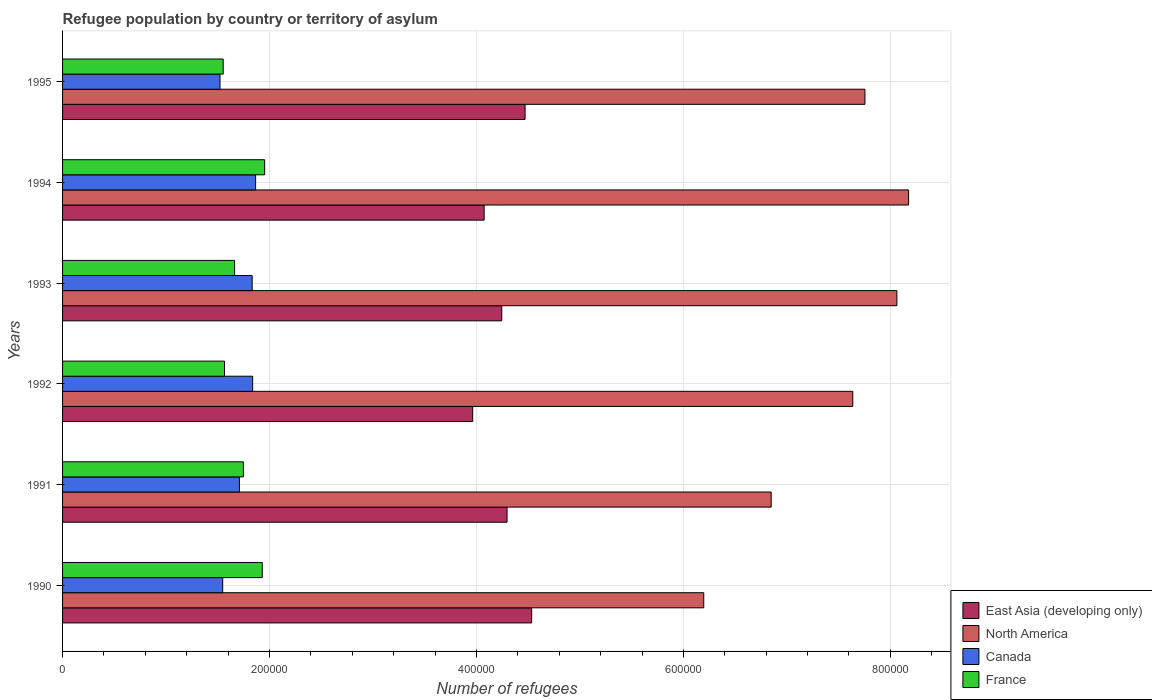How many different coloured bars are there?
Make the answer very short. 4. How many groups of bars are there?
Offer a terse response. 6. Are the number of bars per tick equal to the number of legend labels?
Provide a short and direct response. Yes. How many bars are there on the 5th tick from the top?
Offer a terse response. 4. How many bars are there on the 6th tick from the bottom?
Make the answer very short. 4. In how many cases, is the number of bars for a given year not equal to the number of legend labels?
Ensure brevity in your answer.  0. What is the number of refugees in East Asia (developing only) in 1992?
Provide a succinct answer. 3.96e+05. Across all years, what is the maximum number of refugees in Canada?
Give a very brief answer. 1.87e+05. Across all years, what is the minimum number of refugees in North America?
Your answer should be very brief. 6.20e+05. In which year was the number of refugees in Canada maximum?
Offer a terse response. 1994. In which year was the number of refugees in North America minimum?
Your answer should be compact. 1990. What is the total number of refugees in France in the graph?
Ensure brevity in your answer.  1.04e+06. What is the difference between the number of refugees in France in 1992 and that in 1993?
Your answer should be compact. -9757. What is the difference between the number of refugees in East Asia (developing only) in 1994 and the number of refugees in France in 1991?
Your response must be concise. 2.33e+05. What is the average number of refugees in North America per year?
Your answer should be very brief. 7.45e+05. In the year 1995, what is the difference between the number of refugees in North America and number of refugees in East Asia (developing only)?
Provide a short and direct response. 3.28e+05. In how many years, is the number of refugees in Canada greater than 560000 ?
Provide a short and direct response. 0. What is the ratio of the number of refugees in Canada in 1990 to that in 1992?
Offer a very short reply. 0.84. Is the number of refugees in Canada in 1992 less than that in 1994?
Make the answer very short. Yes. What is the difference between the highest and the second highest number of refugees in North America?
Your answer should be compact. 1.13e+04. What is the difference between the highest and the lowest number of refugees in East Asia (developing only)?
Keep it short and to the point. 5.70e+04. Is the sum of the number of refugees in East Asia (developing only) in 1991 and 1992 greater than the maximum number of refugees in North America across all years?
Your answer should be compact. Yes. What does the 1st bar from the top in 1995 represents?
Provide a succinct answer. France. What does the 2nd bar from the bottom in 1991 represents?
Your answer should be very brief. North America. Is it the case that in every year, the sum of the number of refugees in France and number of refugees in Canada is greater than the number of refugees in East Asia (developing only)?
Offer a very short reply. No. Are all the bars in the graph horizontal?
Provide a succinct answer. Yes. How many years are there in the graph?
Your response must be concise. 6. What is the difference between two consecutive major ticks on the X-axis?
Give a very brief answer. 2.00e+05. Are the values on the major ticks of X-axis written in scientific E-notation?
Provide a short and direct response. No. Does the graph contain grids?
Your response must be concise. Yes. How many legend labels are there?
Your answer should be very brief. 4. What is the title of the graph?
Your response must be concise. Refugee population by country or territory of asylum. What is the label or title of the X-axis?
Provide a succinct answer. Number of refugees. What is the label or title of the Y-axis?
Keep it short and to the point. Years. What is the Number of refugees of East Asia (developing only) in 1990?
Provide a succinct answer. 4.53e+05. What is the Number of refugees in North America in 1990?
Ensure brevity in your answer.  6.20e+05. What is the Number of refugees of Canada in 1990?
Your response must be concise. 1.55e+05. What is the Number of refugees in France in 1990?
Your answer should be compact. 1.93e+05. What is the Number of refugees of East Asia (developing only) in 1991?
Provide a succinct answer. 4.30e+05. What is the Number of refugees of North America in 1991?
Make the answer very short. 6.85e+05. What is the Number of refugees in Canada in 1991?
Your answer should be very brief. 1.71e+05. What is the Number of refugees in France in 1991?
Offer a terse response. 1.75e+05. What is the Number of refugees in East Asia (developing only) in 1992?
Ensure brevity in your answer.  3.96e+05. What is the Number of refugees of North America in 1992?
Your response must be concise. 7.64e+05. What is the Number of refugees in Canada in 1992?
Your answer should be compact. 1.84e+05. What is the Number of refugees in France in 1992?
Give a very brief answer. 1.57e+05. What is the Number of refugees in East Asia (developing only) in 1993?
Your answer should be very brief. 4.24e+05. What is the Number of refugees of North America in 1993?
Your answer should be compact. 8.06e+05. What is the Number of refugees of Canada in 1993?
Your response must be concise. 1.83e+05. What is the Number of refugees in France in 1993?
Your answer should be very brief. 1.66e+05. What is the Number of refugees of East Asia (developing only) in 1994?
Your answer should be very brief. 4.07e+05. What is the Number of refugees in North America in 1994?
Keep it short and to the point. 8.18e+05. What is the Number of refugees of Canada in 1994?
Give a very brief answer. 1.87e+05. What is the Number of refugees in France in 1994?
Keep it short and to the point. 1.95e+05. What is the Number of refugees of East Asia (developing only) in 1995?
Your answer should be compact. 4.47e+05. What is the Number of refugees of North America in 1995?
Offer a terse response. 7.75e+05. What is the Number of refugees of Canada in 1995?
Offer a terse response. 1.52e+05. What is the Number of refugees in France in 1995?
Your answer should be compact. 1.55e+05. Across all years, what is the maximum Number of refugees in East Asia (developing only)?
Offer a very short reply. 4.53e+05. Across all years, what is the maximum Number of refugees in North America?
Your answer should be very brief. 8.18e+05. Across all years, what is the maximum Number of refugees of Canada?
Your response must be concise. 1.87e+05. Across all years, what is the maximum Number of refugees of France?
Offer a terse response. 1.95e+05. Across all years, what is the minimum Number of refugees in East Asia (developing only)?
Make the answer very short. 3.96e+05. Across all years, what is the minimum Number of refugees in North America?
Offer a terse response. 6.20e+05. Across all years, what is the minimum Number of refugees in Canada?
Offer a terse response. 1.52e+05. Across all years, what is the minimum Number of refugees in France?
Your answer should be compact. 1.55e+05. What is the total Number of refugees in East Asia (developing only) in the graph?
Ensure brevity in your answer.  2.56e+06. What is the total Number of refugees in North America in the graph?
Ensure brevity in your answer.  4.47e+06. What is the total Number of refugees of Canada in the graph?
Your response must be concise. 1.03e+06. What is the total Number of refugees in France in the graph?
Make the answer very short. 1.04e+06. What is the difference between the Number of refugees in East Asia (developing only) in 1990 and that in 1991?
Your answer should be compact. 2.38e+04. What is the difference between the Number of refugees of North America in 1990 and that in 1991?
Keep it short and to the point. -6.52e+04. What is the difference between the Number of refugees in Canada in 1990 and that in 1991?
Offer a very short reply. -1.62e+04. What is the difference between the Number of refugees in France in 1990 and that in 1991?
Your answer should be very brief. 1.82e+04. What is the difference between the Number of refugees of East Asia (developing only) in 1990 and that in 1992?
Offer a very short reply. 5.70e+04. What is the difference between the Number of refugees of North America in 1990 and that in 1992?
Offer a terse response. -1.44e+05. What is the difference between the Number of refugees in Canada in 1990 and that in 1992?
Offer a very short reply. -2.90e+04. What is the difference between the Number of refugees in France in 1990 and that in 1992?
Make the answer very short. 3.65e+04. What is the difference between the Number of refugees of East Asia (developing only) in 1990 and that in 1993?
Your answer should be compact. 2.89e+04. What is the difference between the Number of refugees in North America in 1990 and that in 1993?
Make the answer very short. -1.87e+05. What is the difference between the Number of refugees of Canada in 1990 and that in 1993?
Offer a terse response. -2.85e+04. What is the difference between the Number of refugees in France in 1990 and that in 1993?
Make the answer very short. 2.67e+04. What is the difference between the Number of refugees in East Asia (developing only) in 1990 and that in 1994?
Keep it short and to the point. 4.59e+04. What is the difference between the Number of refugees in North America in 1990 and that in 1994?
Your answer should be compact. -1.98e+05. What is the difference between the Number of refugees in Canada in 1990 and that in 1994?
Offer a terse response. -3.18e+04. What is the difference between the Number of refugees of France in 1990 and that in 1994?
Offer a very short reply. -2288. What is the difference between the Number of refugees of East Asia (developing only) in 1990 and that in 1995?
Your answer should be compact. 6367. What is the difference between the Number of refugees of North America in 1990 and that in 1995?
Your answer should be very brief. -1.56e+05. What is the difference between the Number of refugees of Canada in 1990 and that in 1995?
Provide a short and direct response. 2636. What is the difference between the Number of refugees of France in 1990 and that in 1995?
Provide a succinct answer. 3.78e+04. What is the difference between the Number of refugees of East Asia (developing only) in 1991 and that in 1992?
Offer a very short reply. 3.32e+04. What is the difference between the Number of refugees of North America in 1991 and that in 1992?
Provide a succinct answer. -7.89e+04. What is the difference between the Number of refugees in Canada in 1991 and that in 1992?
Provide a succinct answer. -1.28e+04. What is the difference between the Number of refugees of France in 1991 and that in 1992?
Your response must be concise. 1.82e+04. What is the difference between the Number of refugees in East Asia (developing only) in 1991 and that in 1993?
Your answer should be compact. 5099. What is the difference between the Number of refugees in North America in 1991 and that in 1993?
Your answer should be very brief. -1.22e+05. What is the difference between the Number of refugees in Canada in 1991 and that in 1993?
Your answer should be very brief. -1.23e+04. What is the difference between the Number of refugees of France in 1991 and that in 1993?
Make the answer very short. 8487. What is the difference between the Number of refugees in East Asia (developing only) in 1991 and that in 1994?
Offer a very short reply. 2.21e+04. What is the difference between the Number of refugees in North America in 1991 and that in 1994?
Keep it short and to the point. -1.33e+05. What is the difference between the Number of refugees of Canada in 1991 and that in 1994?
Provide a succinct answer. -1.56e+04. What is the difference between the Number of refugees in France in 1991 and that in 1994?
Your answer should be very brief. -2.05e+04. What is the difference between the Number of refugees of East Asia (developing only) in 1991 and that in 1995?
Provide a short and direct response. -1.74e+04. What is the difference between the Number of refugees of North America in 1991 and that in 1995?
Give a very brief answer. -9.06e+04. What is the difference between the Number of refugees of Canada in 1991 and that in 1995?
Your answer should be compact. 1.88e+04. What is the difference between the Number of refugees of France in 1991 and that in 1995?
Offer a terse response. 1.95e+04. What is the difference between the Number of refugees of East Asia (developing only) in 1992 and that in 1993?
Ensure brevity in your answer.  -2.81e+04. What is the difference between the Number of refugees of North America in 1992 and that in 1993?
Provide a short and direct response. -4.26e+04. What is the difference between the Number of refugees of Canada in 1992 and that in 1993?
Ensure brevity in your answer.  482. What is the difference between the Number of refugees in France in 1992 and that in 1993?
Provide a short and direct response. -9757. What is the difference between the Number of refugees in East Asia (developing only) in 1992 and that in 1994?
Provide a short and direct response. -1.11e+04. What is the difference between the Number of refugees of North America in 1992 and that in 1994?
Offer a very short reply. -5.39e+04. What is the difference between the Number of refugees in Canada in 1992 and that in 1994?
Provide a succinct answer. -2840. What is the difference between the Number of refugees in France in 1992 and that in 1994?
Provide a succinct answer. -3.88e+04. What is the difference between the Number of refugees in East Asia (developing only) in 1992 and that in 1995?
Give a very brief answer. -5.06e+04. What is the difference between the Number of refugees of North America in 1992 and that in 1995?
Your response must be concise. -1.17e+04. What is the difference between the Number of refugees of Canada in 1992 and that in 1995?
Your answer should be very brief. 3.16e+04. What is the difference between the Number of refugees in France in 1992 and that in 1995?
Keep it short and to the point. 1267. What is the difference between the Number of refugees in East Asia (developing only) in 1993 and that in 1994?
Make the answer very short. 1.70e+04. What is the difference between the Number of refugees in North America in 1993 and that in 1994?
Make the answer very short. -1.13e+04. What is the difference between the Number of refugees in Canada in 1993 and that in 1994?
Provide a short and direct response. -3322. What is the difference between the Number of refugees in France in 1993 and that in 1994?
Your answer should be very brief. -2.90e+04. What is the difference between the Number of refugees of East Asia (developing only) in 1993 and that in 1995?
Your answer should be very brief. -2.25e+04. What is the difference between the Number of refugees of North America in 1993 and that in 1995?
Keep it short and to the point. 3.09e+04. What is the difference between the Number of refugees of Canada in 1993 and that in 1995?
Provide a succinct answer. 3.11e+04. What is the difference between the Number of refugees in France in 1993 and that in 1995?
Provide a short and direct response. 1.10e+04. What is the difference between the Number of refugees of East Asia (developing only) in 1994 and that in 1995?
Provide a succinct answer. -3.96e+04. What is the difference between the Number of refugees in North America in 1994 and that in 1995?
Your answer should be compact. 4.22e+04. What is the difference between the Number of refugees in Canada in 1994 and that in 1995?
Your answer should be compact. 3.44e+04. What is the difference between the Number of refugees of France in 1994 and that in 1995?
Offer a terse response. 4.00e+04. What is the difference between the Number of refugees in East Asia (developing only) in 1990 and the Number of refugees in North America in 1991?
Provide a short and direct response. -2.31e+05. What is the difference between the Number of refugees in East Asia (developing only) in 1990 and the Number of refugees in Canada in 1991?
Make the answer very short. 2.82e+05. What is the difference between the Number of refugees of East Asia (developing only) in 1990 and the Number of refugees of France in 1991?
Your response must be concise. 2.79e+05. What is the difference between the Number of refugees of North America in 1990 and the Number of refugees of Canada in 1991?
Ensure brevity in your answer.  4.49e+05. What is the difference between the Number of refugees of North America in 1990 and the Number of refugees of France in 1991?
Keep it short and to the point. 4.45e+05. What is the difference between the Number of refugees in Canada in 1990 and the Number of refugees in France in 1991?
Keep it short and to the point. -2.00e+04. What is the difference between the Number of refugees of East Asia (developing only) in 1990 and the Number of refugees of North America in 1992?
Keep it short and to the point. -3.10e+05. What is the difference between the Number of refugees in East Asia (developing only) in 1990 and the Number of refugees in Canada in 1992?
Provide a short and direct response. 2.70e+05. What is the difference between the Number of refugees of East Asia (developing only) in 1990 and the Number of refugees of France in 1992?
Provide a short and direct response. 2.97e+05. What is the difference between the Number of refugees of North America in 1990 and the Number of refugees of Canada in 1992?
Your response must be concise. 4.36e+05. What is the difference between the Number of refugees of North America in 1990 and the Number of refugees of France in 1992?
Give a very brief answer. 4.63e+05. What is the difference between the Number of refugees in Canada in 1990 and the Number of refugees in France in 1992?
Your answer should be very brief. -1751. What is the difference between the Number of refugees in East Asia (developing only) in 1990 and the Number of refugees in North America in 1993?
Offer a terse response. -3.53e+05. What is the difference between the Number of refugees in East Asia (developing only) in 1990 and the Number of refugees in Canada in 1993?
Your answer should be very brief. 2.70e+05. What is the difference between the Number of refugees of East Asia (developing only) in 1990 and the Number of refugees of France in 1993?
Keep it short and to the point. 2.87e+05. What is the difference between the Number of refugees in North America in 1990 and the Number of refugees in Canada in 1993?
Your answer should be very brief. 4.36e+05. What is the difference between the Number of refugees in North America in 1990 and the Number of refugees in France in 1993?
Offer a very short reply. 4.53e+05. What is the difference between the Number of refugees in Canada in 1990 and the Number of refugees in France in 1993?
Make the answer very short. -1.15e+04. What is the difference between the Number of refugees of East Asia (developing only) in 1990 and the Number of refugees of North America in 1994?
Your response must be concise. -3.64e+05. What is the difference between the Number of refugees in East Asia (developing only) in 1990 and the Number of refugees in Canada in 1994?
Provide a succinct answer. 2.67e+05. What is the difference between the Number of refugees of East Asia (developing only) in 1990 and the Number of refugees of France in 1994?
Provide a short and direct response. 2.58e+05. What is the difference between the Number of refugees in North America in 1990 and the Number of refugees in Canada in 1994?
Provide a succinct answer. 4.33e+05. What is the difference between the Number of refugees of North America in 1990 and the Number of refugees of France in 1994?
Ensure brevity in your answer.  4.24e+05. What is the difference between the Number of refugees of Canada in 1990 and the Number of refugees of France in 1994?
Your answer should be compact. -4.05e+04. What is the difference between the Number of refugees in East Asia (developing only) in 1990 and the Number of refugees in North America in 1995?
Your response must be concise. -3.22e+05. What is the difference between the Number of refugees in East Asia (developing only) in 1990 and the Number of refugees in Canada in 1995?
Your answer should be compact. 3.01e+05. What is the difference between the Number of refugees in East Asia (developing only) in 1990 and the Number of refugees in France in 1995?
Ensure brevity in your answer.  2.98e+05. What is the difference between the Number of refugees in North America in 1990 and the Number of refugees in Canada in 1995?
Offer a very short reply. 4.68e+05. What is the difference between the Number of refugees of North America in 1990 and the Number of refugees of France in 1995?
Offer a very short reply. 4.64e+05. What is the difference between the Number of refugees of Canada in 1990 and the Number of refugees of France in 1995?
Your answer should be very brief. -484. What is the difference between the Number of refugees of East Asia (developing only) in 1991 and the Number of refugees of North America in 1992?
Provide a succinct answer. -3.34e+05. What is the difference between the Number of refugees in East Asia (developing only) in 1991 and the Number of refugees in Canada in 1992?
Your answer should be compact. 2.46e+05. What is the difference between the Number of refugees of East Asia (developing only) in 1991 and the Number of refugees of France in 1992?
Your response must be concise. 2.73e+05. What is the difference between the Number of refugees in North America in 1991 and the Number of refugees in Canada in 1992?
Provide a short and direct response. 5.01e+05. What is the difference between the Number of refugees of North America in 1991 and the Number of refugees of France in 1992?
Your response must be concise. 5.28e+05. What is the difference between the Number of refugees in Canada in 1991 and the Number of refugees in France in 1992?
Ensure brevity in your answer.  1.44e+04. What is the difference between the Number of refugees in East Asia (developing only) in 1991 and the Number of refugees in North America in 1993?
Ensure brevity in your answer.  -3.77e+05. What is the difference between the Number of refugees of East Asia (developing only) in 1991 and the Number of refugees of Canada in 1993?
Your response must be concise. 2.46e+05. What is the difference between the Number of refugees in East Asia (developing only) in 1991 and the Number of refugees in France in 1993?
Provide a short and direct response. 2.63e+05. What is the difference between the Number of refugees in North America in 1991 and the Number of refugees in Canada in 1993?
Make the answer very short. 5.02e+05. What is the difference between the Number of refugees in North America in 1991 and the Number of refugees in France in 1993?
Make the answer very short. 5.19e+05. What is the difference between the Number of refugees in Canada in 1991 and the Number of refugees in France in 1993?
Provide a succinct answer. 4647. What is the difference between the Number of refugees in East Asia (developing only) in 1991 and the Number of refugees in North America in 1994?
Offer a very short reply. -3.88e+05. What is the difference between the Number of refugees of East Asia (developing only) in 1991 and the Number of refugees of Canada in 1994?
Provide a short and direct response. 2.43e+05. What is the difference between the Number of refugees of East Asia (developing only) in 1991 and the Number of refugees of France in 1994?
Make the answer very short. 2.34e+05. What is the difference between the Number of refugees in North America in 1991 and the Number of refugees in Canada in 1994?
Keep it short and to the point. 4.98e+05. What is the difference between the Number of refugees of North America in 1991 and the Number of refugees of France in 1994?
Your response must be concise. 4.90e+05. What is the difference between the Number of refugees in Canada in 1991 and the Number of refugees in France in 1994?
Your answer should be compact. -2.44e+04. What is the difference between the Number of refugees of East Asia (developing only) in 1991 and the Number of refugees of North America in 1995?
Ensure brevity in your answer.  -3.46e+05. What is the difference between the Number of refugees in East Asia (developing only) in 1991 and the Number of refugees in Canada in 1995?
Your answer should be very brief. 2.77e+05. What is the difference between the Number of refugees in East Asia (developing only) in 1991 and the Number of refugees in France in 1995?
Offer a terse response. 2.74e+05. What is the difference between the Number of refugees of North America in 1991 and the Number of refugees of Canada in 1995?
Your answer should be very brief. 5.33e+05. What is the difference between the Number of refugees of North America in 1991 and the Number of refugees of France in 1995?
Provide a short and direct response. 5.30e+05. What is the difference between the Number of refugees of Canada in 1991 and the Number of refugees of France in 1995?
Ensure brevity in your answer.  1.57e+04. What is the difference between the Number of refugees of East Asia (developing only) in 1992 and the Number of refugees of North America in 1993?
Offer a very short reply. -4.10e+05. What is the difference between the Number of refugees of East Asia (developing only) in 1992 and the Number of refugees of Canada in 1993?
Offer a very short reply. 2.13e+05. What is the difference between the Number of refugees in East Asia (developing only) in 1992 and the Number of refugees in France in 1993?
Your answer should be compact. 2.30e+05. What is the difference between the Number of refugees of North America in 1992 and the Number of refugees of Canada in 1993?
Offer a very short reply. 5.80e+05. What is the difference between the Number of refugees of North America in 1992 and the Number of refugees of France in 1993?
Give a very brief answer. 5.97e+05. What is the difference between the Number of refugees of Canada in 1992 and the Number of refugees of France in 1993?
Provide a succinct answer. 1.75e+04. What is the difference between the Number of refugees of East Asia (developing only) in 1992 and the Number of refugees of North America in 1994?
Offer a terse response. -4.21e+05. What is the difference between the Number of refugees in East Asia (developing only) in 1992 and the Number of refugees in Canada in 1994?
Provide a succinct answer. 2.10e+05. What is the difference between the Number of refugees in East Asia (developing only) in 1992 and the Number of refugees in France in 1994?
Provide a succinct answer. 2.01e+05. What is the difference between the Number of refugees of North America in 1992 and the Number of refugees of Canada in 1994?
Your response must be concise. 5.77e+05. What is the difference between the Number of refugees of North America in 1992 and the Number of refugees of France in 1994?
Your response must be concise. 5.68e+05. What is the difference between the Number of refugees in Canada in 1992 and the Number of refugees in France in 1994?
Give a very brief answer. -1.16e+04. What is the difference between the Number of refugees of East Asia (developing only) in 1992 and the Number of refugees of North America in 1995?
Your response must be concise. -3.79e+05. What is the difference between the Number of refugees in East Asia (developing only) in 1992 and the Number of refugees in Canada in 1995?
Keep it short and to the point. 2.44e+05. What is the difference between the Number of refugees in East Asia (developing only) in 1992 and the Number of refugees in France in 1995?
Offer a very short reply. 2.41e+05. What is the difference between the Number of refugees in North America in 1992 and the Number of refugees in Canada in 1995?
Your answer should be very brief. 6.12e+05. What is the difference between the Number of refugees of North America in 1992 and the Number of refugees of France in 1995?
Offer a terse response. 6.08e+05. What is the difference between the Number of refugees of Canada in 1992 and the Number of refugees of France in 1995?
Give a very brief answer. 2.85e+04. What is the difference between the Number of refugees of East Asia (developing only) in 1993 and the Number of refugees of North America in 1994?
Ensure brevity in your answer.  -3.93e+05. What is the difference between the Number of refugees of East Asia (developing only) in 1993 and the Number of refugees of Canada in 1994?
Make the answer very short. 2.38e+05. What is the difference between the Number of refugees of East Asia (developing only) in 1993 and the Number of refugees of France in 1994?
Your response must be concise. 2.29e+05. What is the difference between the Number of refugees of North America in 1993 and the Number of refugees of Canada in 1994?
Provide a succinct answer. 6.20e+05. What is the difference between the Number of refugees in North America in 1993 and the Number of refugees in France in 1994?
Offer a terse response. 6.11e+05. What is the difference between the Number of refugees of Canada in 1993 and the Number of refugees of France in 1994?
Your answer should be very brief. -1.20e+04. What is the difference between the Number of refugees in East Asia (developing only) in 1993 and the Number of refugees in North America in 1995?
Your response must be concise. -3.51e+05. What is the difference between the Number of refugees in East Asia (developing only) in 1993 and the Number of refugees in Canada in 1995?
Ensure brevity in your answer.  2.72e+05. What is the difference between the Number of refugees in East Asia (developing only) in 1993 and the Number of refugees in France in 1995?
Keep it short and to the point. 2.69e+05. What is the difference between the Number of refugees in North America in 1993 and the Number of refugees in Canada in 1995?
Provide a succinct answer. 6.54e+05. What is the difference between the Number of refugees of North America in 1993 and the Number of refugees of France in 1995?
Your answer should be compact. 6.51e+05. What is the difference between the Number of refugees in Canada in 1993 and the Number of refugees in France in 1995?
Provide a succinct answer. 2.80e+04. What is the difference between the Number of refugees of East Asia (developing only) in 1994 and the Number of refugees of North America in 1995?
Your answer should be compact. -3.68e+05. What is the difference between the Number of refugees in East Asia (developing only) in 1994 and the Number of refugees in Canada in 1995?
Provide a succinct answer. 2.55e+05. What is the difference between the Number of refugees in East Asia (developing only) in 1994 and the Number of refugees in France in 1995?
Provide a short and direct response. 2.52e+05. What is the difference between the Number of refugees in North America in 1994 and the Number of refugees in Canada in 1995?
Provide a short and direct response. 6.65e+05. What is the difference between the Number of refugees of North America in 1994 and the Number of refugees of France in 1995?
Make the answer very short. 6.62e+05. What is the difference between the Number of refugees of Canada in 1994 and the Number of refugees of France in 1995?
Ensure brevity in your answer.  3.13e+04. What is the average Number of refugees in East Asia (developing only) per year?
Provide a short and direct response. 4.26e+05. What is the average Number of refugees of North America per year?
Ensure brevity in your answer.  7.45e+05. What is the average Number of refugees in Canada per year?
Your response must be concise. 1.72e+05. What is the average Number of refugees in France per year?
Make the answer very short. 1.74e+05. In the year 1990, what is the difference between the Number of refugees of East Asia (developing only) and Number of refugees of North America?
Make the answer very short. -1.66e+05. In the year 1990, what is the difference between the Number of refugees of East Asia (developing only) and Number of refugees of Canada?
Ensure brevity in your answer.  2.99e+05. In the year 1990, what is the difference between the Number of refugees in East Asia (developing only) and Number of refugees in France?
Offer a very short reply. 2.60e+05. In the year 1990, what is the difference between the Number of refugees in North America and Number of refugees in Canada?
Keep it short and to the point. 4.65e+05. In the year 1990, what is the difference between the Number of refugees of North America and Number of refugees of France?
Your answer should be very brief. 4.27e+05. In the year 1990, what is the difference between the Number of refugees of Canada and Number of refugees of France?
Offer a terse response. -3.82e+04. In the year 1991, what is the difference between the Number of refugees of East Asia (developing only) and Number of refugees of North America?
Ensure brevity in your answer.  -2.55e+05. In the year 1991, what is the difference between the Number of refugees in East Asia (developing only) and Number of refugees in Canada?
Keep it short and to the point. 2.59e+05. In the year 1991, what is the difference between the Number of refugees in East Asia (developing only) and Number of refugees in France?
Ensure brevity in your answer.  2.55e+05. In the year 1991, what is the difference between the Number of refugees in North America and Number of refugees in Canada?
Offer a terse response. 5.14e+05. In the year 1991, what is the difference between the Number of refugees of North America and Number of refugees of France?
Provide a short and direct response. 5.10e+05. In the year 1991, what is the difference between the Number of refugees in Canada and Number of refugees in France?
Your answer should be very brief. -3840. In the year 1992, what is the difference between the Number of refugees of East Asia (developing only) and Number of refugees of North America?
Your response must be concise. -3.67e+05. In the year 1992, what is the difference between the Number of refugees of East Asia (developing only) and Number of refugees of Canada?
Provide a short and direct response. 2.13e+05. In the year 1992, what is the difference between the Number of refugees in East Asia (developing only) and Number of refugees in France?
Provide a short and direct response. 2.40e+05. In the year 1992, what is the difference between the Number of refugees of North America and Number of refugees of Canada?
Your response must be concise. 5.80e+05. In the year 1992, what is the difference between the Number of refugees of North America and Number of refugees of France?
Your answer should be very brief. 6.07e+05. In the year 1992, what is the difference between the Number of refugees of Canada and Number of refugees of France?
Ensure brevity in your answer.  2.72e+04. In the year 1993, what is the difference between the Number of refugees of East Asia (developing only) and Number of refugees of North America?
Offer a very short reply. -3.82e+05. In the year 1993, what is the difference between the Number of refugees in East Asia (developing only) and Number of refugees in Canada?
Your answer should be very brief. 2.41e+05. In the year 1993, what is the difference between the Number of refugees in East Asia (developing only) and Number of refugees in France?
Offer a very short reply. 2.58e+05. In the year 1993, what is the difference between the Number of refugees of North America and Number of refugees of Canada?
Make the answer very short. 6.23e+05. In the year 1993, what is the difference between the Number of refugees in North America and Number of refugees in France?
Your response must be concise. 6.40e+05. In the year 1993, what is the difference between the Number of refugees of Canada and Number of refugees of France?
Your answer should be compact. 1.70e+04. In the year 1994, what is the difference between the Number of refugees of East Asia (developing only) and Number of refugees of North America?
Your response must be concise. -4.10e+05. In the year 1994, what is the difference between the Number of refugees in East Asia (developing only) and Number of refugees in Canada?
Provide a short and direct response. 2.21e+05. In the year 1994, what is the difference between the Number of refugees in East Asia (developing only) and Number of refugees in France?
Ensure brevity in your answer.  2.12e+05. In the year 1994, what is the difference between the Number of refugees of North America and Number of refugees of Canada?
Your response must be concise. 6.31e+05. In the year 1994, what is the difference between the Number of refugees in North America and Number of refugees in France?
Your answer should be very brief. 6.22e+05. In the year 1994, what is the difference between the Number of refugees of Canada and Number of refugees of France?
Your answer should be compact. -8725. In the year 1995, what is the difference between the Number of refugees in East Asia (developing only) and Number of refugees in North America?
Your response must be concise. -3.28e+05. In the year 1995, what is the difference between the Number of refugees in East Asia (developing only) and Number of refugees in Canada?
Provide a succinct answer. 2.95e+05. In the year 1995, what is the difference between the Number of refugees of East Asia (developing only) and Number of refugees of France?
Offer a very short reply. 2.92e+05. In the year 1995, what is the difference between the Number of refugees of North America and Number of refugees of Canada?
Provide a succinct answer. 6.23e+05. In the year 1995, what is the difference between the Number of refugees in North America and Number of refugees in France?
Give a very brief answer. 6.20e+05. In the year 1995, what is the difference between the Number of refugees of Canada and Number of refugees of France?
Your answer should be compact. -3120. What is the ratio of the Number of refugees in East Asia (developing only) in 1990 to that in 1991?
Offer a very short reply. 1.06. What is the ratio of the Number of refugees in North America in 1990 to that in 1991?
Give a very brief answer. 0.9. What is the ratio of the Number of refugees of Canada in 1990 to that in 1991?
Ensure brevity in your answer.  0.91. What is the ratio of the Number of refugees in France in 1990 to that in 1991?
Make the answer very short. 1.1. What is the ratio of the Number of refugees in East Asia (developing only) in 1990 to that in 1992?
Your answer should be very brief. 1.14. What is the ratio of the Number of refugees of North America in 1990 to that in 1992?
Make the answer very short. 0.81. What is the ratio of the Number of refugees of Canada in 1990 to that in 1992?
Ensure brevity in your answer.  0.84. What is the ratio of the Number of refugees of France in 1990 to that in 1992?
Your answer should be compact. 1.23. What is the ratio of the Number of refugees in East Asia (developing only) in 1990 to that in 1993?
Give a very brief answer. 1.07. What is the ratio of the Number of refugees in North America in 1990 to that in 1993?
Offer a terse response. 0.77. What is the ratio of the Number of refugees of Canada in 1990 to that in 1993?
Make the answer very short. 0.84. What is the ratio of the Number of refugees in France in 1990 to that in 1993?
Give a very brief answer. 1.16. What is the ratio of the Number of refugees of East Asia (developing only) in 1990 to that in 1994?
Make the answer very short. 1.11. What is the ratio of the Number of refugees of North America in 1990 to that in 1994?
Ensure brevity in your answer.  0.76. What is the ratio of the Number of refugees of Canada in 1990 to that in 1994?
Your answer should be very brief. 0.83. What is the ratio of the Number of refugees in France in 1990 to that in 1994?
Your response must be concise. 0.99. What is the ratio of the Number of refugees in East Asia (developing only) in 1990 to that in 1995?
Make the answer very short. 1.01. What is the ratio of the Number of refugees of North America in 1990 to that in 1995?
Your response must be concise. 0.8. What is the ratio of the Number of refugees of Canada in 1990 to that in 1995?
Offer a terse response. 1.02. What is the ratio of the Number of refugees of France in 1990 to that in 1995?
Make the answer very short. 1.24. What is the ratio of the Number of refugees of East Asia (developing only) in 1991 to that in 1992?
Your answer should be compact. 1.08. What is the ratio of the Number of refugees in North America in 1991 to that in 1992?
Your answer should be very brief. 0.9. What is the ratio of the Number of refugees in Canada in 1991 to that in 1992?
Your answer should be very brief. 0.93. What is the ratio of the Number of refugees of France in 1991 to that in 1992?
Offer a very short reply. 1.12. What is the ratio of the Number of refugees of East Asia (developing only) in 1991 to that in 1993?
Provide a short and direct response. 1.01. What is the ratio of the Number of refugees in North America in 1991 to that in 1993?
Your answer should be very brief. 0.85. What is the ratio of the Number of refugees in Canada in 1991 to that in 1993?
Make the answer very short. 0.93. What is the ratio of the Number of refugees of France in 1991 to that in 1993?
Your answer should be very brief. 1.05. What is the ratio of the Number of refugees of East Asia (developing only) in 1991 to that in 1994?
Keep it short and to the point. 1.05. What is the ratio of the Number of refugees of North America in 1991 to that in 1994?
Your response must be concise. 0.84. What is the ratio of the Number of refugees of Canada in 1991 to that in 1994?
Your response must be concise. 0.92. What is the ratio of the Number of refugees of France in 1991 to that in 1994?
Your answer should be very brief. 0.89. What is the ratio of the Number of refugees in East Asia (developing only) in 1991 to that in 1995?
Your answer should be very brief. 0.96. What is the ratio of the Number of refugees in North America in 1991 to that in 1995?
Provide a succinct answer. 0.88. What is the ratio of the Number of refugees of Canada in 1991 to that in 1995?
Provide a short and direct response. 1.12. What is the ratio of the Number of refugees of France in 1991 to that in 1995?
Ensure brevity in your answer.  1.13. What is the ratio of the Number of refugees of East Asia (developing only) in 1992 to that in 1993?
Offer a very short reply. 0.93. What is the ratio of the Number of refugees in North America in 1992 to that in 1993?
Give a very brief answer. 0.95. What is the ratio of the Number of refugees of Canada in 1992 to that in 1993?
Your answer should be very brief. 1. What is the ratio of the Number of refugees in France in 1992 to that in 1993?
Make the answer very short. 0.94. What is the ratio of the Number of refugees of East Asia (developing only) in 1992 to that in 1994?
Offer a terse response. 0.97. What is the ratio of the Number of refugees of North America in 1992 to that in 1994?
Provide a short and direct response. 0.93. What is the ratio of the Number of refugees in France in 1992 to that in 1994?
Offer a terse response. 0.8. What is the ratio of the Number of refugees of East Asia (developing only) in 1992 to that in 1995?
Your answer should be compact. 0.89. What is the ratio of the Number of refugees in North America in 1992 to that in 1995?
Provide a succinct answer. 0.98. What is the ratio of the Number of refugees in Canada in 1992 to that in 1995?
Offer a very short reply. 1.21. What is the ratio of the Number of refugees of France in 1992 to that in 1995?
Keep it short and to the point. 1.01. What is the ratio of the Number of refugees of East Asia (developing only) in 1993 to that in 1994?
Ensure brevity in your answer.  1.04. What is the ratio of the Number of refugees in North America in 1993 to that in 1994?
Your answer should be compact. 0.99. What is the ratio of the Number of refugees in Canada in 1993 to that in 1994?
Provide a short and direct response. 0.98. What is the ratio of the Number of refugees in France in 1993 to that in 1994?
Keep it short and to the point. 0.85. What is the ratio of the Number of refugees of East Asia (developing only) in 1993 to that in 1995?
Offer a very short reply. 0.95. What is the ratio of the Number of refugees of North America in 1993 to that in 1995?
Provide a succinct answer. 1.04. What is the ratio of the Number of refugees of Canada in 1993 to that in 1995?
Offer a very short reply. 1.2. What is the ratio of the Number of refugees of France in 1993 to that in 1995?
Provide a succinct answer. 1.07. What is the ratio of the Number of refugees of East Asia (developing only) in 1994 to that in 1995?
Your answer should be very brief. 0.91. What is the ratio of the Number of refugees in North America in 1994 to that in 1995?
Offer a terse response. 1.05. What is the ratio of the Number of refugees in Canada in 1994 to that in 1995?
Provide a short and direct response. 1.23. What is the ratio of the Number of refugees in France in 1994 to that in 1995?
Keep it short and to the point. 1.26. What is the difference between the highest and the second highest Number of refugees in East Asia (developing only)?
Give a very brief answer. 6367. What is the difference between the highest and the second highest Number of refugees in North America?
Offer a terse response. 1.13e+04. What is the difference between the highest and the second highest Number of refugees of Canada?
Provide a short and direct response. 2840. What is the difference between the highest and the second highest Number of refugees of France?
Offer a very short reply. 2288. What is the difference between the highest and the lowest Number of refugees in East Asia (developing only)?
Provide a short and direct response. 5.70e+04. What is the difference between the highest and the lowest Number of refugees of North America?
Your answer should be compact. 1.98e+05. What is the difference between the highest and the lowest Number of refugees of Canada?
Give a very brief answer. 3.44e+04. What is the difference between the highest and the lowest Number of refugees of France?
Offer a very short reply. 4.00e+04. 